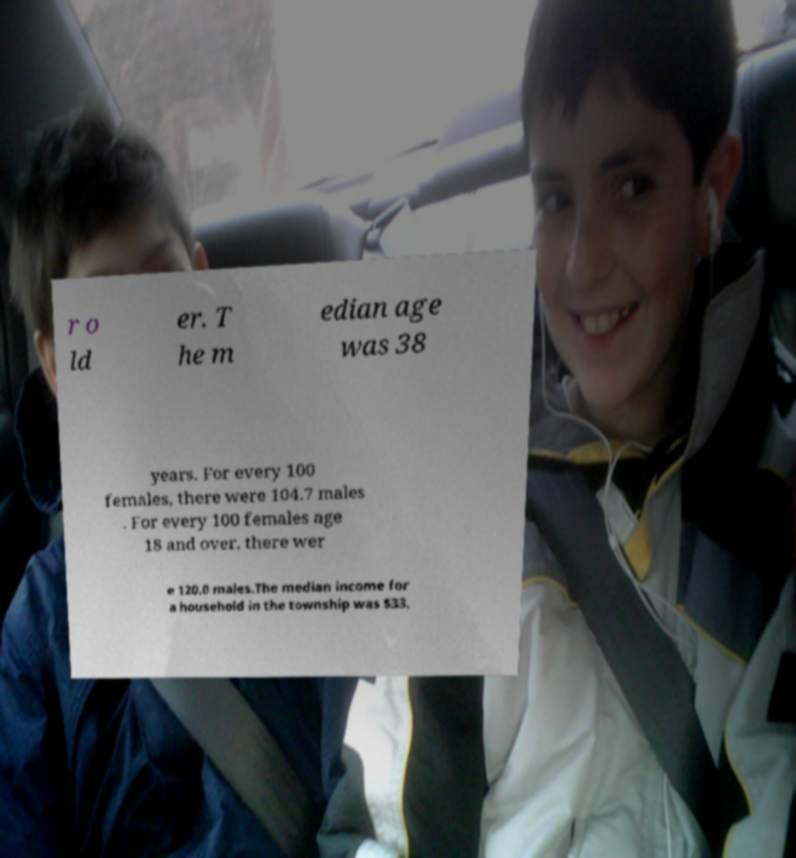There's text embedded in this image that I need extracted. Can you transcribe it verbatim? r o ld er. T he m edian age was 38 years. For every 100 females, there were 104.7 males . For every 100 females age 18 and over, there wer e 120.0 males.The median income for a household in the township was $33, 